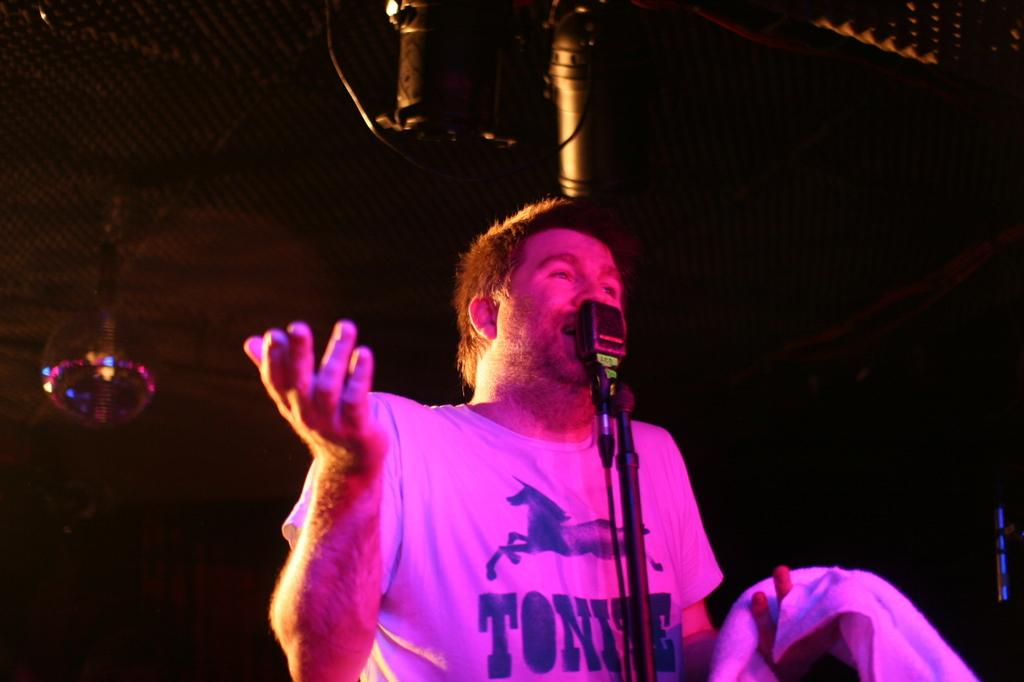Who or what is the main subject in the image? There is a person in the image. What is the person interacting with in the image? There is a mic in front of the person. What can be seen behind the person in the image? There are objects behind the person. How would you describe the lighting in the image? The background of the image is dark. What type of animal can be seen interacting with the person in the image? There is no animal present in the image; it features a person with a mic and objects in the background. What impulse might the person be experiencing while holding the mic in the image? The image does not provide information about the person's emotions or impulses, so it cannot be determined from the image. 